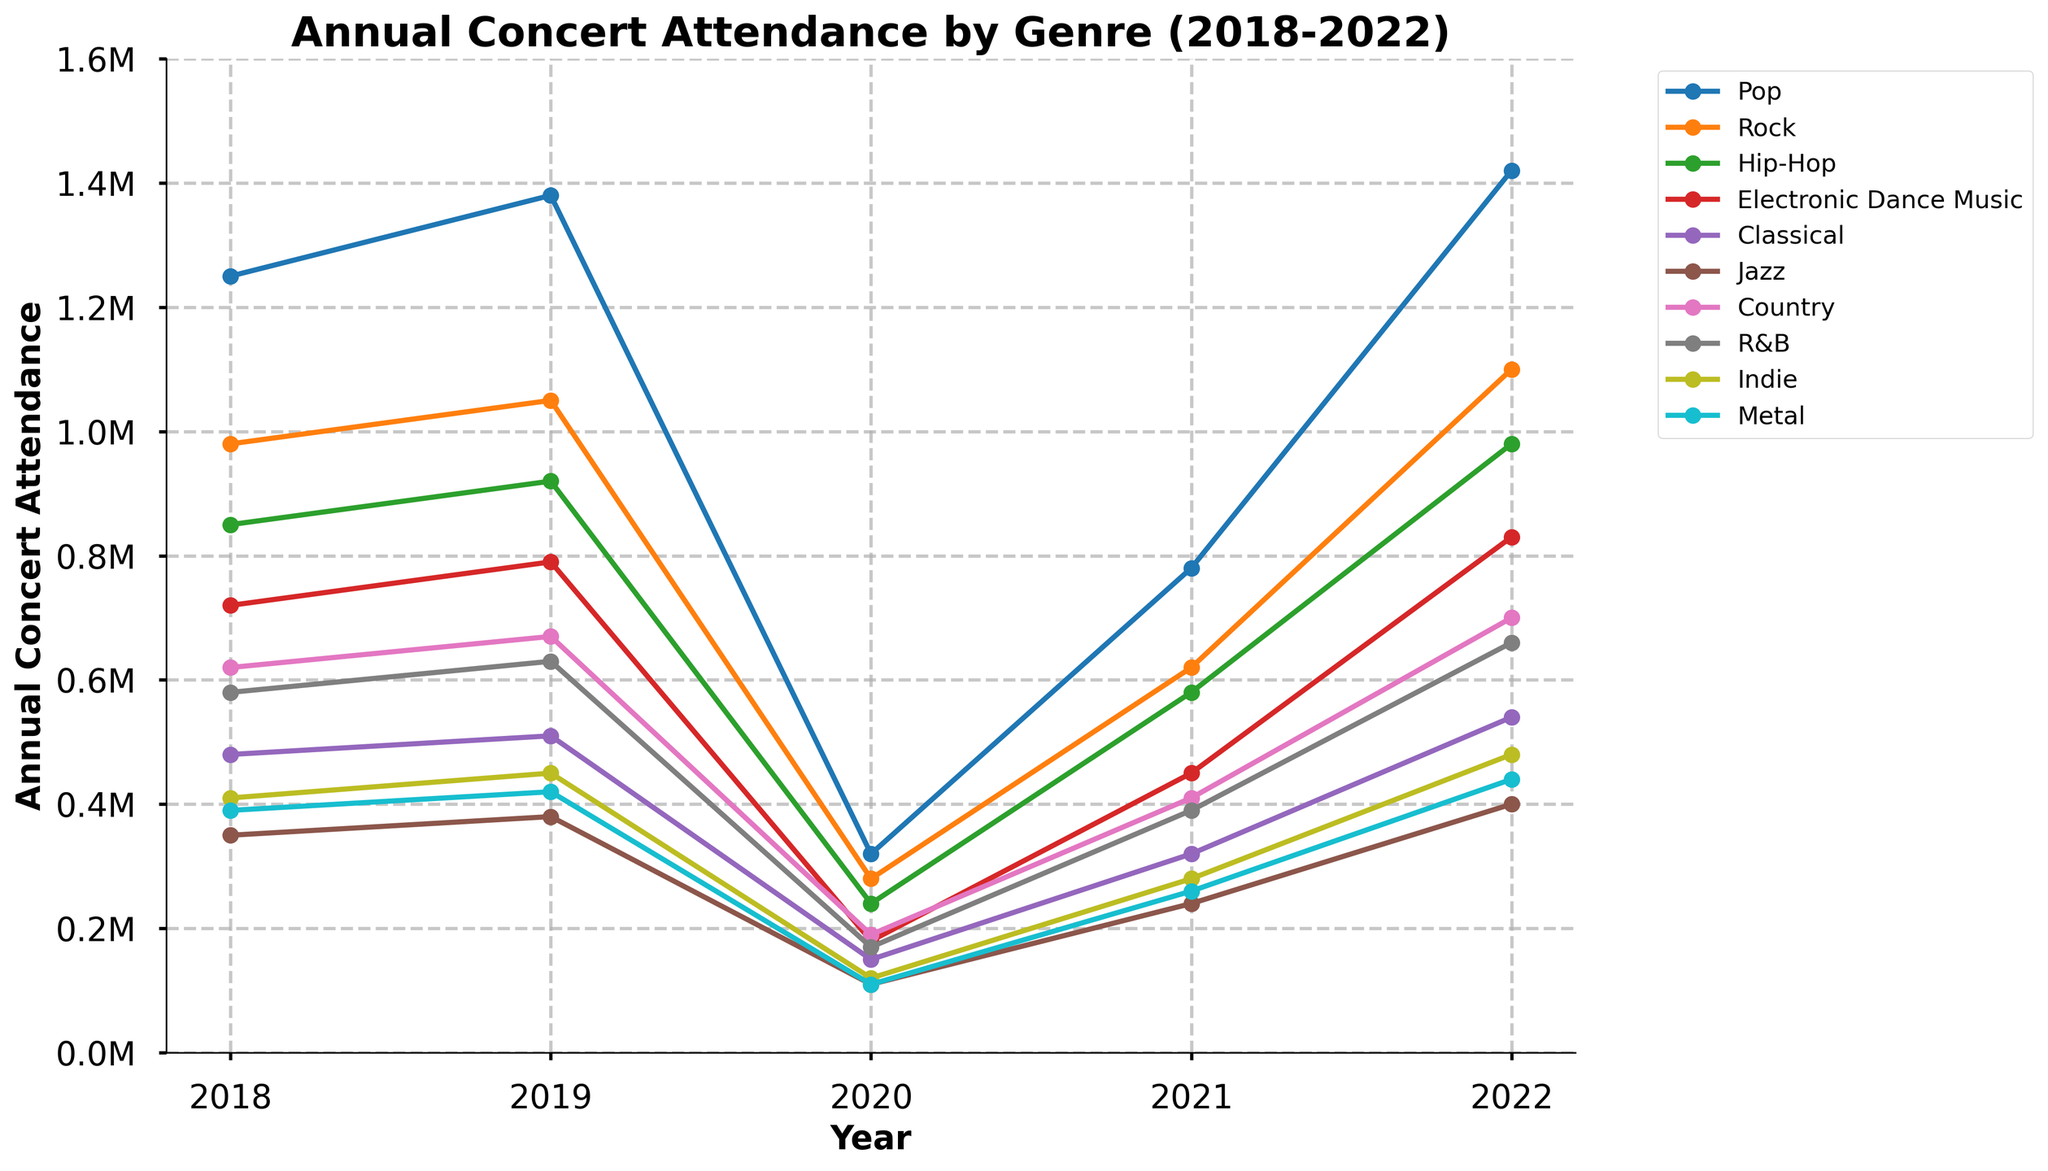Which genre had the highest concert attendance in 2022? Look at the concert attendance values for each genre in 2022. The highest value is 1,420,000 for Pop.
Answer: Pop Which genre had the lowest concert attendance in 2020? Compare the concert attendance values for each genre in 2020. The lowest value is 110,000 for both Jazz and Metal.
Answer: Jazz and Metal What was the total concert attendance for Rock and Hip-Hop in 2021? Sum the concert attendance values for Rock and Hip-Hop in 2021. For Rock, it is 620,000 and for Hip-Hop, it is 580,000. The total is 620,000 + 580,000 = 1,200,000.
Answer: 1,200,000 Which genre showed the largest increase in concert attendance from 2021 to 2022? Calculate the difference in concert attendance from 2021 to 2022 for each genre and identify the largest increase. For Pop, the difference is 1,420,000 - 780,000 = 640,000. This is the largest increase.
Answer: Pop What was the average concert attendance for Classical music from 2018 to 2022? Sum the concert attendance values for Classical music over the years 2018 to 2022 and divide by the number of years. The values are 480,000, 510,000, 150,000, 320,000, and 540,000. The total is 2,000,000. The average is 2,000,000 / 5 = 400,000.
Answer: 400,000 Which two genres had similar attendance trends between 2018 and 2022? Observe the lines in the chart and compare the trends. Country and R&B had similar attendance trends, both showing a dip in 2020 and recovery through 2021 and 2022.
Answer: Country and R&B How did the attendance for Electronic Dance Music in 2021 compare to that of Indie in the same year? Look at the attendance values for Electronic Dance Music and Indie in 2021. For Electronic Dance Music, it is 450,000 and for Indie, it is 280,000. Electronic Dance Music had a higher attendance.
Answer: Electronic Dance Music What was the difference in concert attendance between Pop and Metal in 2019? Subtract the attendance value of Metal from that of Pop in 2019. For Pop, it is 1,380,000 and for Metal, it is 420,000. The difference is 1,380,000 - 420,000 = 960,000.
Answer: 960,000 What is the trend observed for concert attendance for Jazz music from 2018 to 2022? Observe the values for Jazz music from 2018 to 2022 and describe the trend. Jazz music attendance decreased from 350,000 in 2018 to 110,000 in 2020, then increased again to 400,000 by 2022.
Answer: Decrease and then increase 